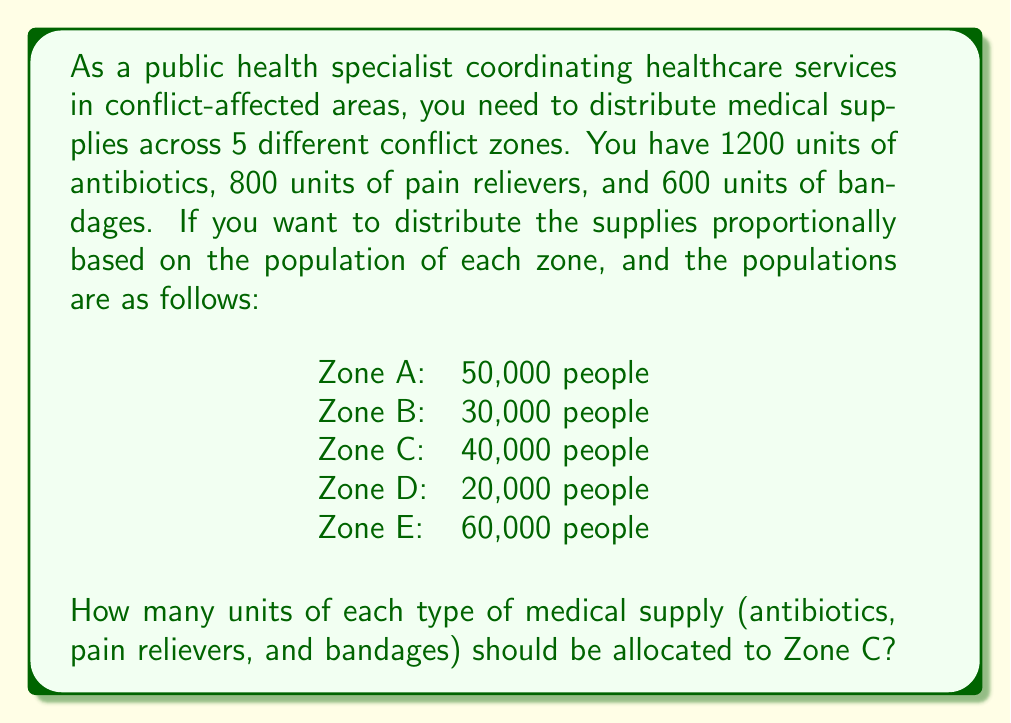Solve this math problem. To solve this problem, we need to follow these steps:

1. Calculate the total population across all zones:
   $$ \text{Total Population} = 50,000 + 30,000 + 40,000 + 20,000 + 60,000 = 200,000 $$

2. Calculate the proportion of the total population in Zone C:
   $$ \text{Zone C Proportion} = \frac{40,000}{200,000} = 0.2 \text{ or } 20\% $$

3. Calculate the number of units for each type of medical supply for Zone C:

   For antibiotics:
   $$ \text{Zone C Antibiotics} = 1200 \times 0.2 = 240 \text{ units} $$

   For pain relievers:
   $$ \text{Zone C Pain Relievers} = 800 \times 0.2 = 160 \text{ units} $$

   For bandages:
   $$ \text{Zone C Bandages} = 600 \times 0.2 = 120 \text{ units} $$

Therefore, Zone C should receive 240 units of antibiotics, 160 units of pain relievers, and 120 units of bandages.
Answer: Zone C should be allocated 240 units of antibiotics, 160 units of pain relievers, and 120 units of bandages. 